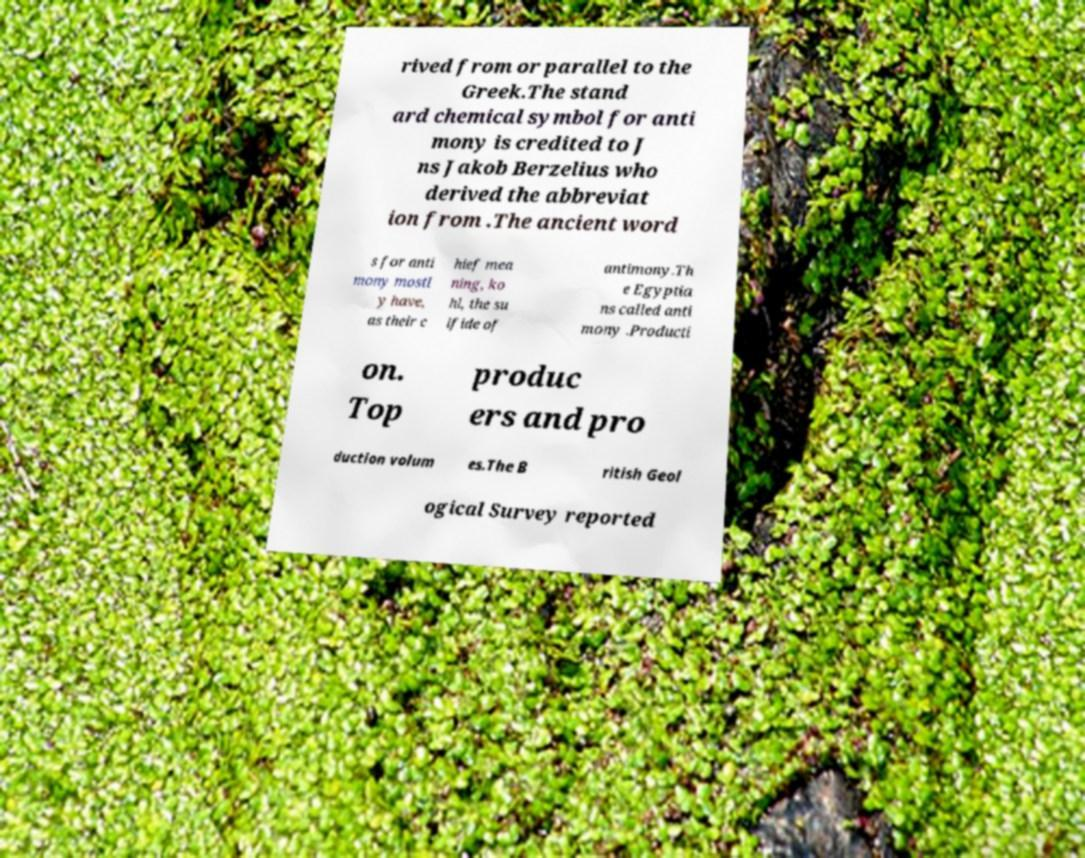Please identify and transcribe the text found in this image. rived from or parallel to the Greek.The stand ard chemical symbol for anti mony is credited to J ns Jakob Berzelius who derived the abbreviat ion from .The ancient word s for anti mony mostl y have, as their c hief mea ning, ko hl, the su lfide of antimony.Th e Egyptia ns called anti mony .Producti on. Top produc ers and pro duction volum es.The B ritish Geol ogical Survey reported 